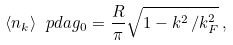Convert formula to latex. <formula><loc_0><loc_0><loc_500><loc_500>\langle n _ { k } \rangle ^ { \ } p d a g _ { 0 } = \frac { R } { \pi } \sqrt { 1 - k ^ { 2 } \, / k _ { F } ^ { 2 } } \, ,</formula> 